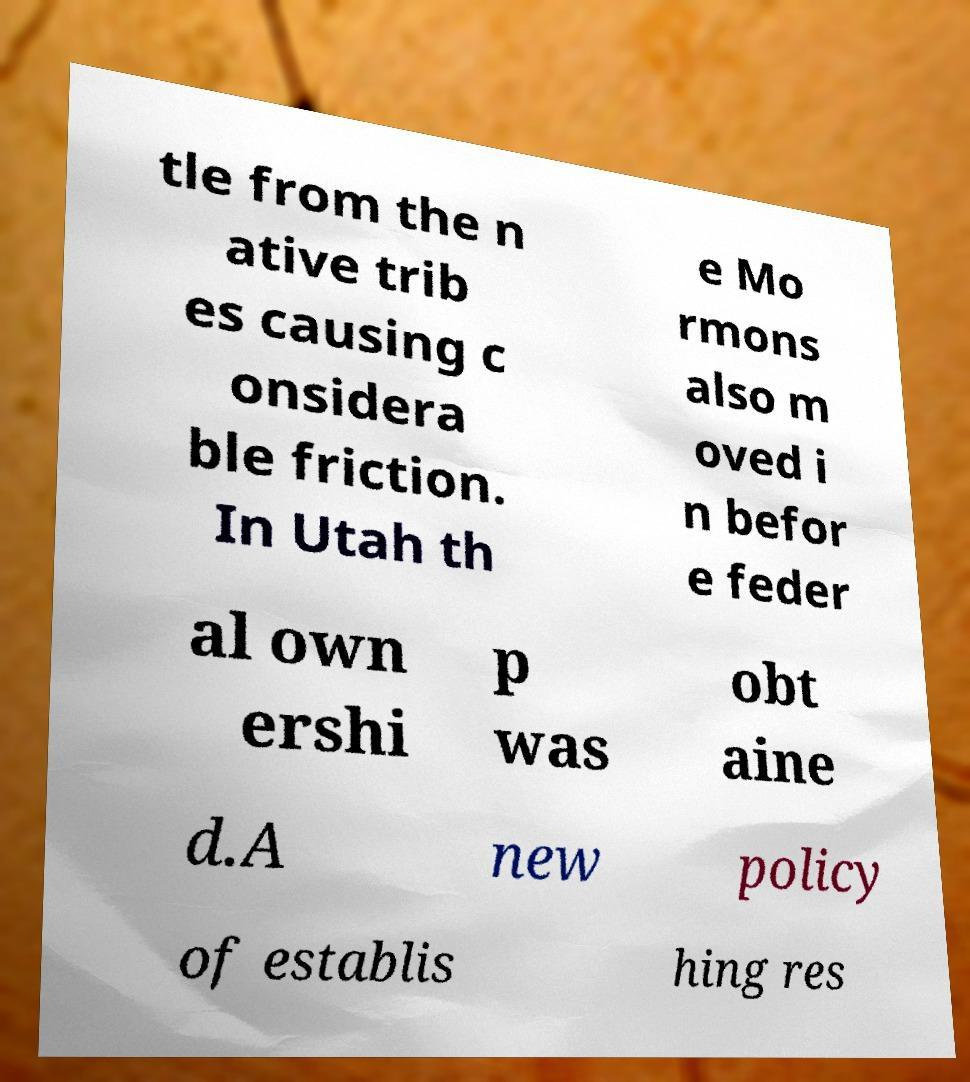Please identify and transcribe the text found in this image. tle from the n ative trib es causing c onsidera ble friction. In Utah th e Mo rmons also m oved i n befor e feder al own ershi p was obt aine d.A new policy of establis hing res 